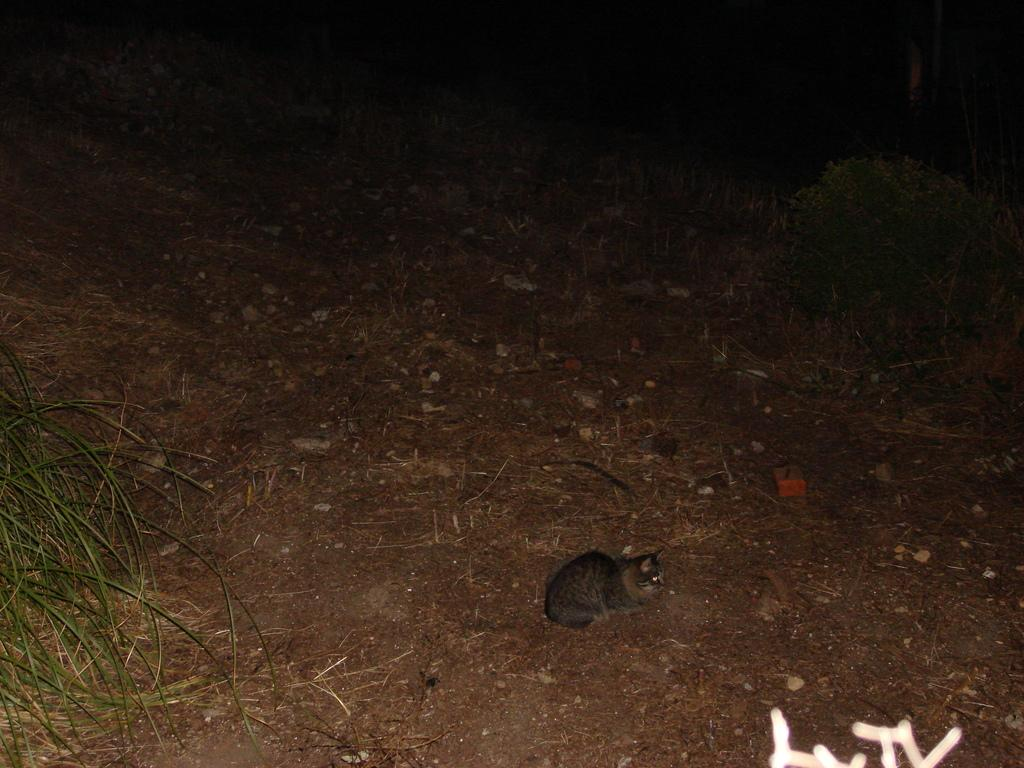What type of animal is in the image? There is a cat in the image. Where is the cat located in the image? The cat is on the ground. What type of vegetation can be seen in the image? There is grass visible in the image. How would you describe the lighting in the image? The background of the image is dark. What type of disgust can be seen on the cat's face in the image? There is no indication of disgust on the cat's face in the image. Can you describe the roof in the image? There is no roof present in the image. 